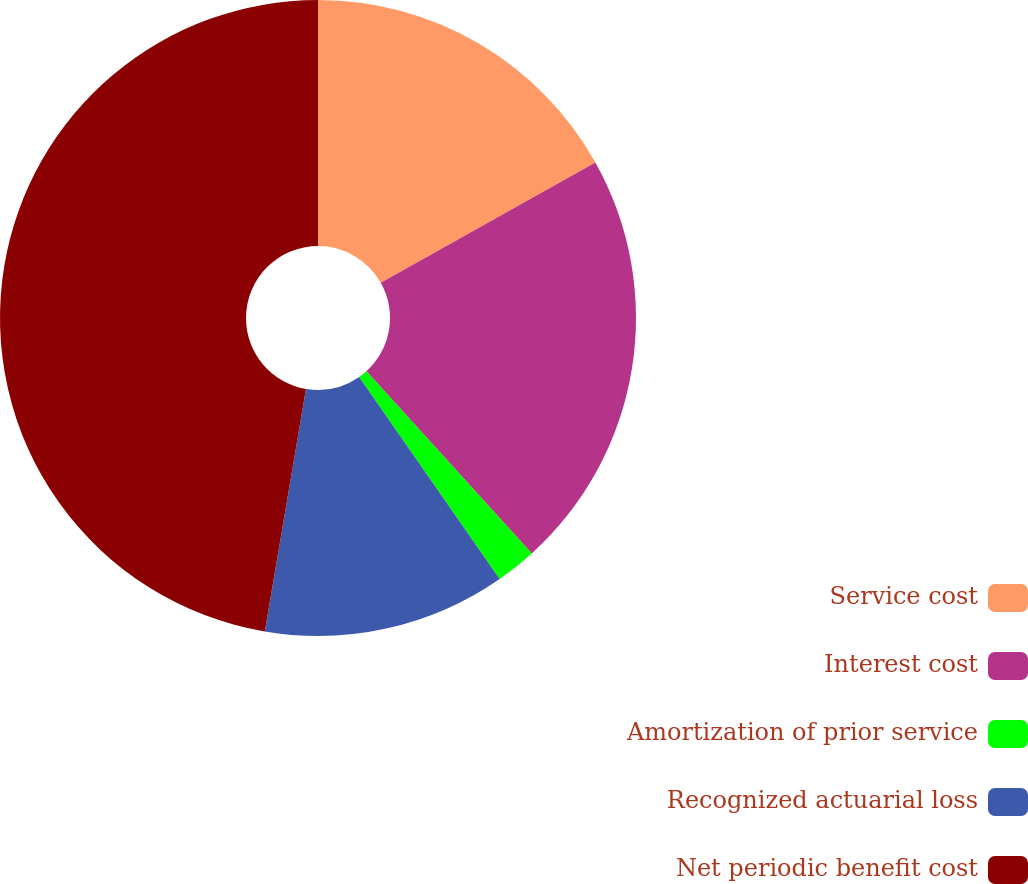Convert chart. <chart><loc_0><loc_0><loc_500><loc_500><pie_chart><fcel>Service cost<fcel>Interest cost<fcel>Amortization of prior service<fcel>Recognized actuarial loss<fcel>Net periodic benefit cost<nl><fcel>16.87%<fcel>21.4%<fcel>2.06%<fcel>12.35%<fcel>47.33%<nl></chart> 